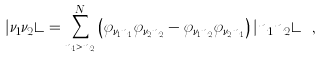Convert formula to latex. <formula><loc_0><loc_0><loc_500><loc_500>| \nu _ { 1 } \nu _ { 2 } \rangle = \sum _ { n _ { 1 } > n _ { 2 } } ^ { N } \left ( \varphi _ { \nu _ { 1 } n _ { 1 } } \varphi _ { \nu _ { 2 } n _ { 2 } } - \varphi _ { \nu _ { 1 } n _ { 2 } } \varphi _ { \nu _ { 2 } n _ { 1 } } \right ) | n _ { 1 } n _ { 2 } \rangle \ ,</formula> 